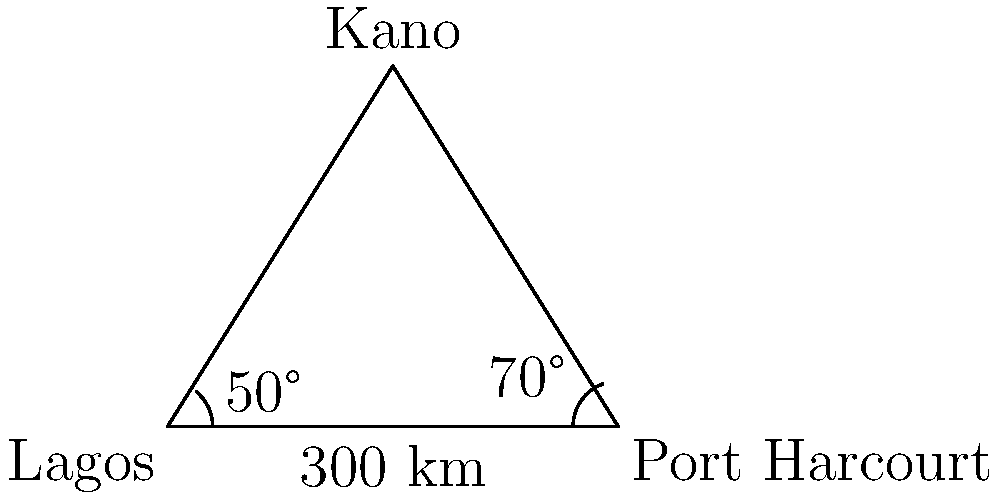During your political campaign travels in the 1980s, you frequently visited three major Nigerian cities: Lagos, Port Harcourt, and Kano. You know that the distance between Lagos and Port Harcourt is 300 km. The angle formed at Lagos between the routes to Port Harcourt and Kano is 50°, while the angle formed at Port Harcourt between the routes to Lagos and Kano is 70°. Using the law of cosines, calculate the distance between Lagos and Kano to the nearest kilometer. Let's approach this step-by-step using the law of cosines:

1) Let's define our variables:
   a = distance between Lagos and Kano (what we're solving for)
   b = 300 km (distance between Lagos and Port Harcourt)
   c = distance between Port Harcourt and Kano
   A = 50° (angle at Lagos)
   B = 70° (angle at Port Harcourt)
   C = 180° - (50° + 70°) = 60° (angle at Kano)

2) The law of cosines states: $a^2 = b^2 + c^2 - 2bc \cos(A)$

3) We know b and A, but we don't know c. However, we can use the law of sines to find it:
   $\frac{b}{\sin(C)} = \frac{c}{\sin(A)}$

4) Rearranging this: $c = \frac{b \sin(A)}{\sin(C)}$

5) Plugging in our values:
   $c = \frac{300 \sin(50°)}{\sin(60°)} \approx 268.74$ km

6) Now we can use the law of cosines:
   $a^2 = 300^2 + 268.74^2 - 2(300)(268.74) \cos(50°)$

7) Simplifying:
   $a^2 = 90000 + 72221.32 - 103752.95 \cos(50°)$
   $a^2 = 162221.32 - 66682.53$
   $a^2 = 95538.79$

8) Taking the square root:
   $a = \sqrt{95538.79} \approx 309.09$ km

9) Rounding to the nearest kilometer:
   $a \approx 309$ km

Therefore, the distance between Lagos and Kano is approximately 309 km.
Answer: 309 km 